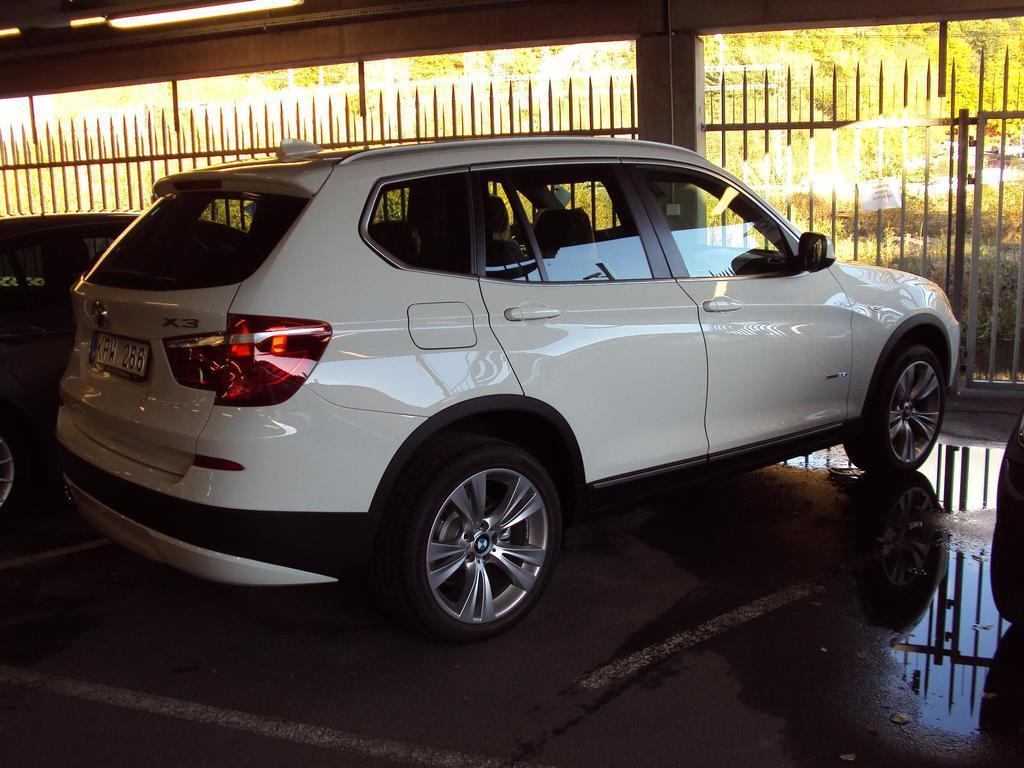Describe this image in one or two sentences. In this image there are three vehicles on the path, and at the background there are iron grills, plants, trees,lights. 